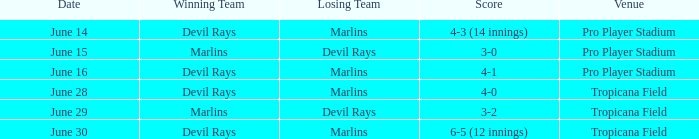On june 14, what was the winning score by the devil rays in pro player stadium? 4-3 (14 innings). 